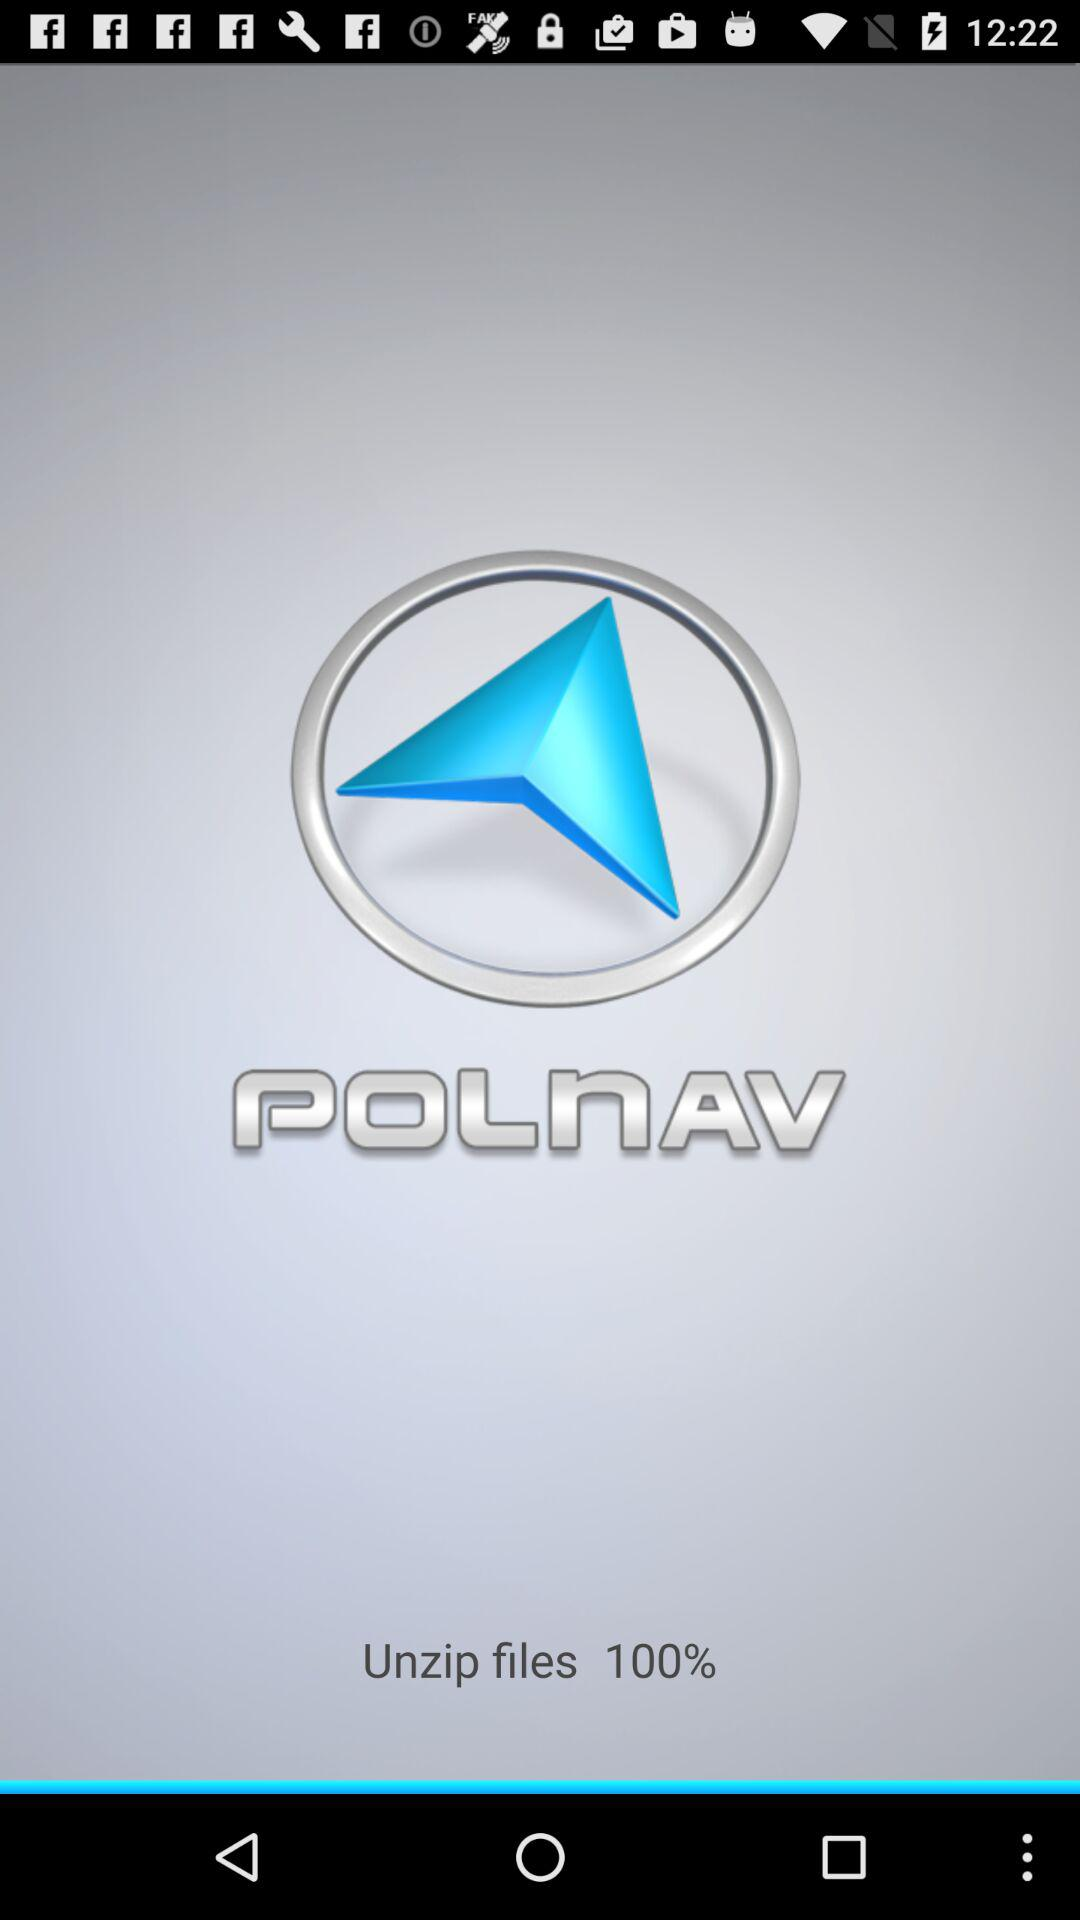What is the name of the application? The name of the application is "Polnav". 